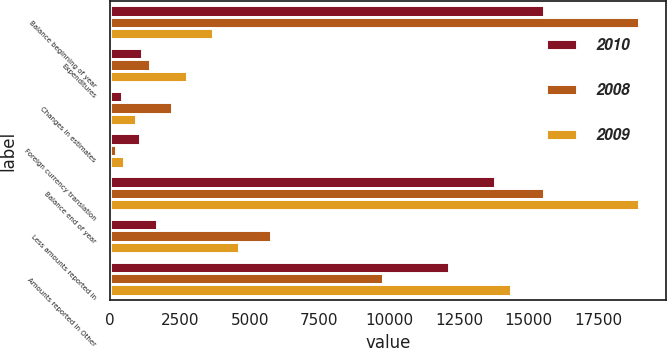<chart> <loc_0><loc_0><loc_500><loc_500><stacked_bar_chart><ecel><fcel>Balance beginning of year<fcel>Expenditures<fcel>Changes in estimates<fcel>Foreign currency translation<fcel>Balance end of year<fcel>Less amounts reported in<fcel>Amounts reported in Other<nl><fcel>2010<fcel>15567<fcel>1128<fcel>419<fcel>1052<fcel>13806<fcel>1661<fcel>12145<nl><fcel>2008<fcel>18970<fcel>1414<fcel>2202<fcel>213<fcel>15567<fcel>5775<fcel>9792<nl><fcel>2009<fcel>3673.5<fcel>2742<fcel>916<fcel>488<fcel>18970<fcel>4605<fcel>14365<nl></chart> 